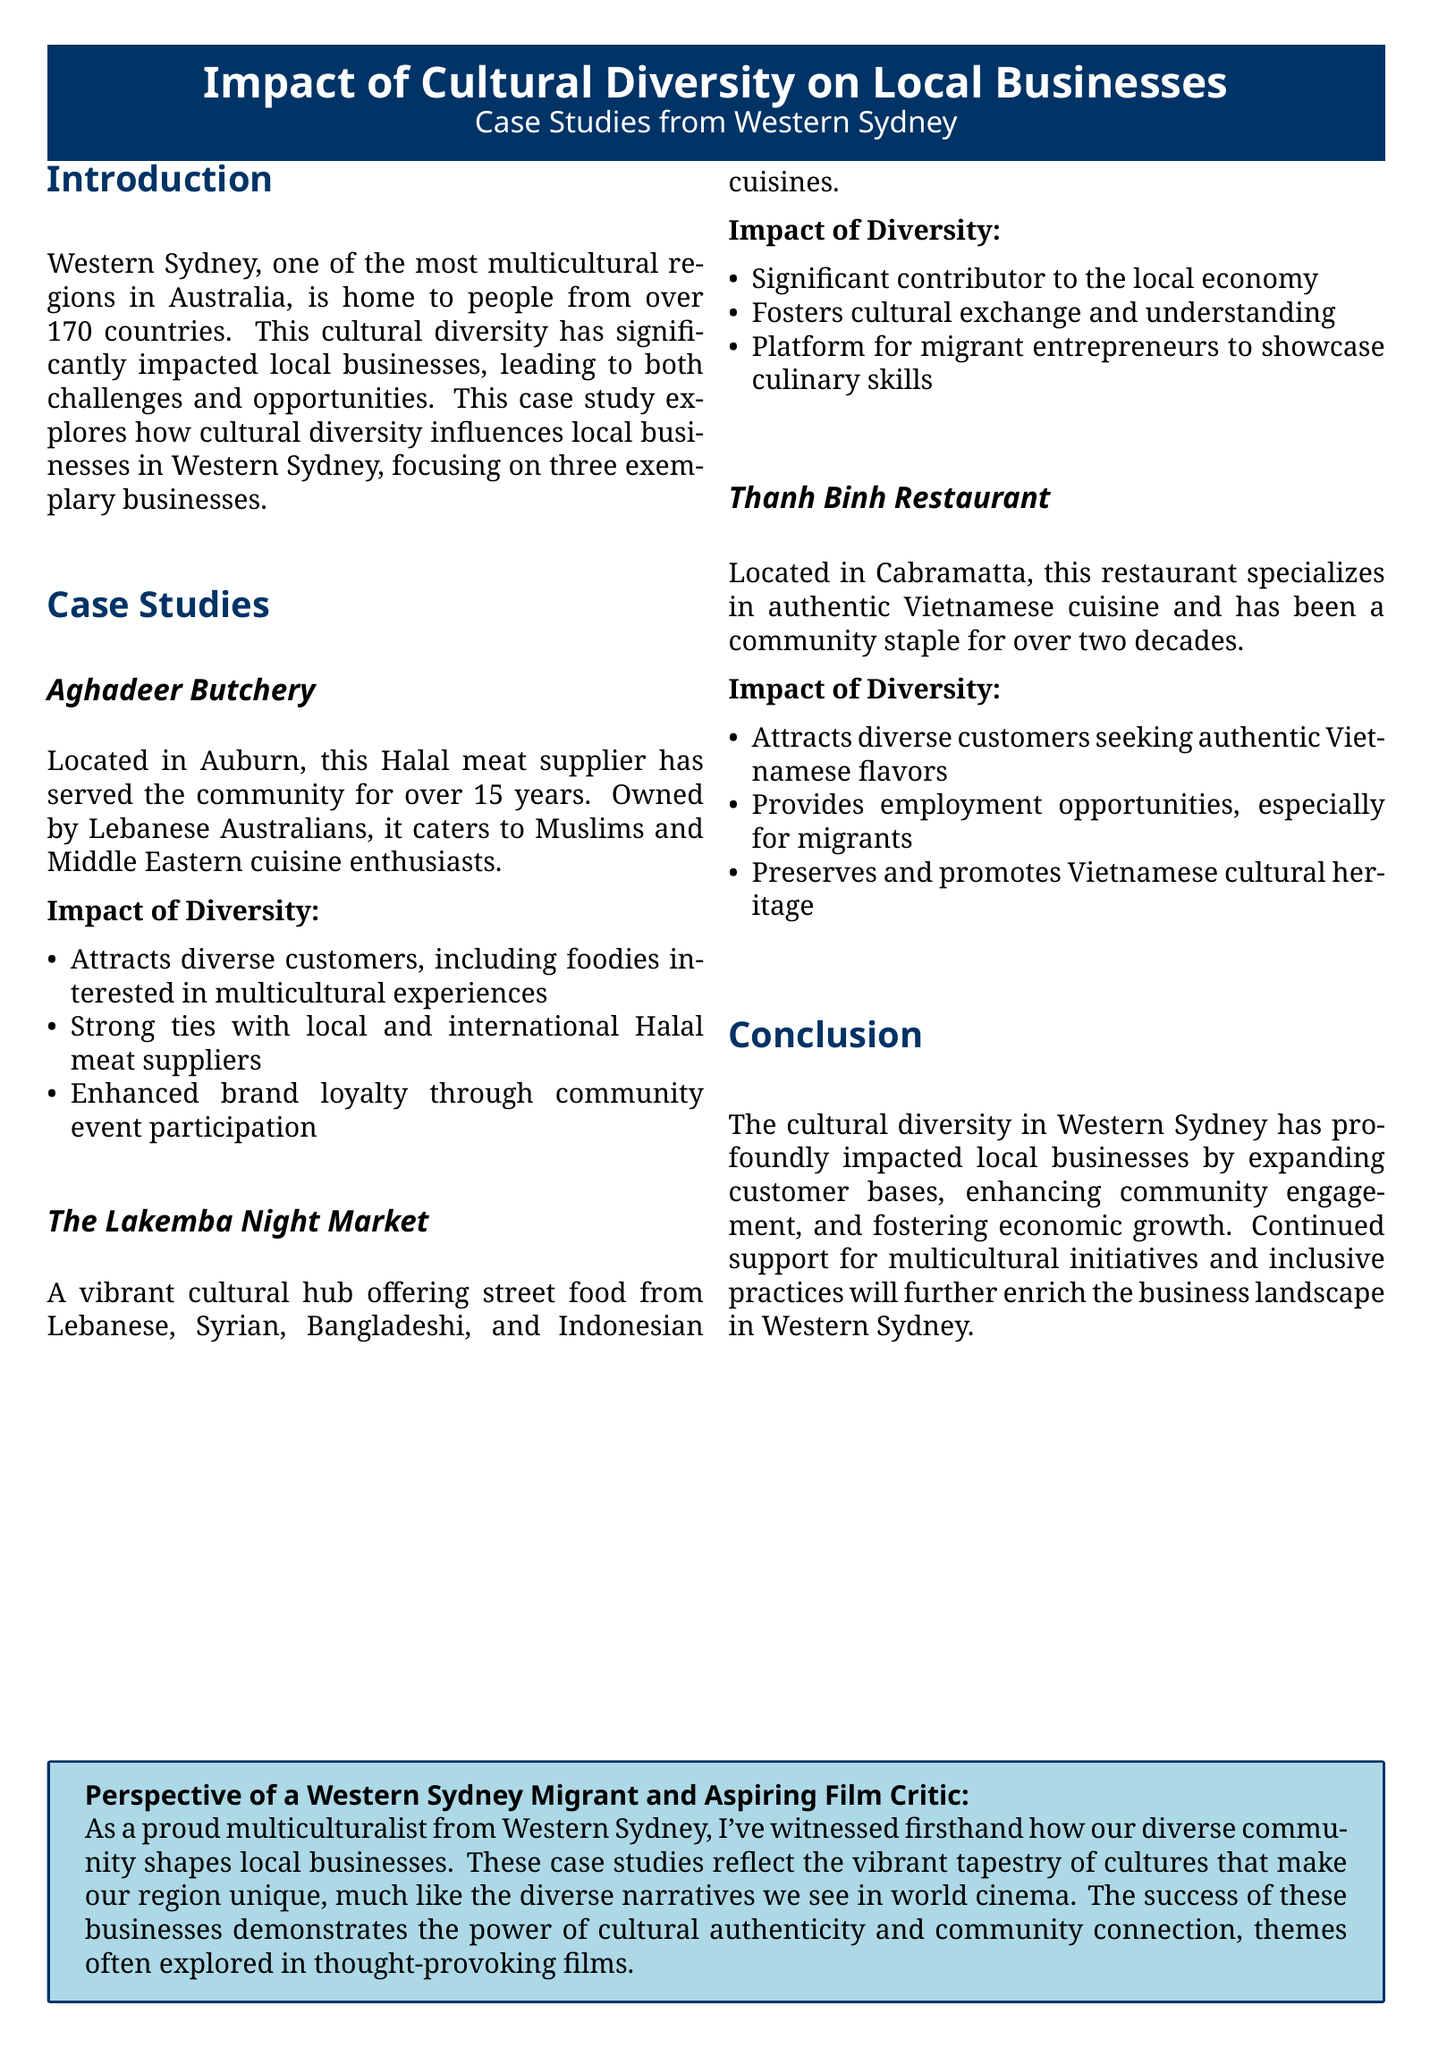What is the name of the Halal meat supplier in Auburn? The document mentions Aghadeer Butchery as the Halal meat supplier located in Auburn.
Answer: Aghadeer Butchery How long has Thanh Binh Restaurant been a community staple? The document states that Thanh Binh Restaurant has been a community staple for over two decades.
Answer: Over two decades What type of cuisine does Aghadeer Butchery cater to? It caters to Muslims and Middle Eastern cuisine enthusiasts.
Answer: Muslims and Middle Eastern cuisine What is the main contribution of The Lakemba Night Market to the local economy? The document notes that it is a significant contributor to the local economy.
Answer: Significant contributor Which cultural heritage does Thanh Binh Restaurant promote? The document highlights that it preserves and promotes Vietnamese cultural heritage.
Answer: Vietnamese cultural heritage What is a notable impact of cultural diversity on local businesses mentioned in the conclusion? The conclusion discusses expanded customer bases as a notable impact of cultural diversity.
Answer: Expanded customer bases How many countries are represented in the population of Western Sydney? The document indicates that Western Sydney is home to people from over 170 countries.
Answer: Over 170 countries What common theme is shared between local businesses and world cinema, according to the perspective section? The document suggests that the common theme is the power of cultural authenticity and community connection.
Answer: Cultural authenticity and community connection 